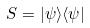Convert formula to latex. <formula><loc_0><loc_0><loc_500><loc_500>S = | \psi \rangle \langle \psi |</formula> 